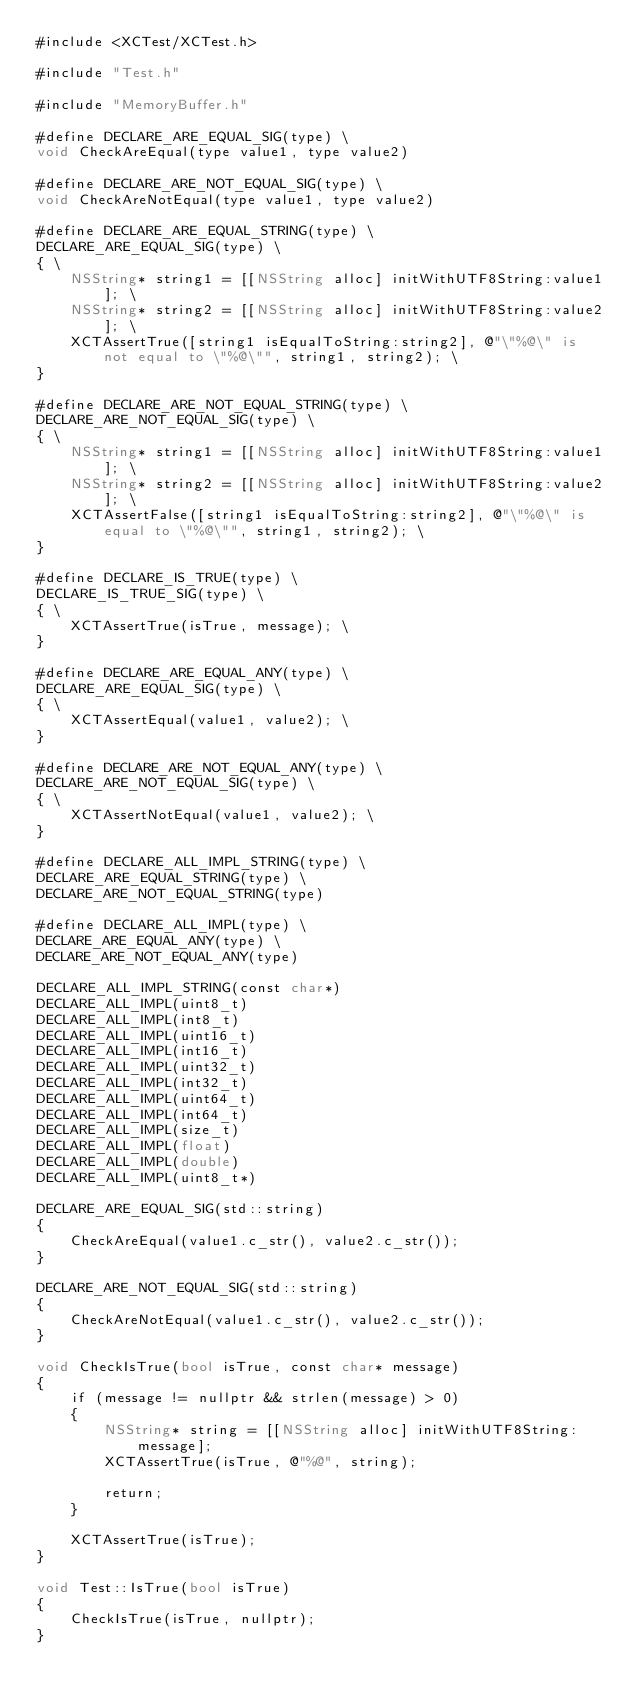Convert code to text. <code><loc_0><loc_0><loc_500><loc_500><_ObjectiveC_>#include <XCTest/XCTest.h>

#include "Test.h"

#include "MemoryBuffer.h"

#define DECLARE_ARE_EQUAL_SIG(type) \
void CheckAreEqual(type value1, type value2)

#define DECLARE_ARE_NOT_EQUAL_SIG(type) \
void CheckAreNotEqual(type value1, type value2)

#define DECLARE_ARE_EQUAL_STRING(type) \
DECLARE_ARE_EQUAL_SIG(type) \
{ \
    NSString* string1 = [[NSString alloc] initWithUTF8String:value1]; \
    NSString* string2 = [[NSString alloc] initWithUTF8String:value2]; \
    XCTAssertTrue([string1 isEqualToString:string2], @"\"%@\" is not equal to \"%@\"", string1, string2); \
}

#define DECLARE_ARE_NOT_EQUAL_STRING(type) \
DECLARE_ARE_NOT_EQUAL_SIG(type) \
{ \
    NSString* string1 = [[NSString alloc] initWithUTF8String:value1]; \
    NSString* string2 = [[NSString alloc] initWithUTF8String:value2]; \
    XCTAssertFalse([string1 isEqualToString:string2], @"\"%@\" is equal to \"%@\"", string1, string2); \
}

#define DECLARE_IS_TRUE(type) \
DECLARE_IS_TRUE_SIG(type) \
{ \
    XCTAssertTrue(isTrue, message); \
}

#define DECLARE_ARE_EQUAL_ANY(type) \
DECLARE_ARE_EQUAL_SIG(type) \
{ \
    XCTAssertEqual(value1, value2); \
}

#define DECLARE_ARE_NOT_EQUAL_ANY(type) \
DECLARE_ARE_NOT_EQUAL_SIG(type) \
{ \
    XCTAssertNotEqual(value1, value2); \
}

#define DECLARE_ALL_IMPL_STRING(type) \
DECLARE_ARE_EQUAL_STRING(type) \
DECLARE_ARE_NOT_EQUAL_STRING(type)

#define DECLARE_ALL_IMPL(type) \
DECLARE_ARE_EQUAL_ANY(type) \
DECLARE_ARE_NOT_EQUAL_ANY(type)

DECLARE_ALL_IMPL_STRING(const char*)
DECLARE_ALL_IMPL(uint8_t)
DECLARE_ALL_IMPL(int8_t)
DECLARE_ALL_IMPL(uint16_t)
DECLARE_ALL_IMPL(int16_t)
DECLARE_ALL_IMPL(uint32_t)
DECLARE_ALL_IMPL(int32_t)
DECLARE_ALL_IMPL(uint64_t)
DECLARE_ALL_IMPL(int64_t)
DECLARE_ALL_IMPL(size_t)
DECLARE_ALL_IMPL(float)
DECLARE_ALL_IMPL(double)
DECLARE_ALL_IMPL(uint8_t*)

DECLARE_ARE_EQUAL_SIG(std::string)
{
    CheckAreEqual(value1.c_str(), value2.c_str());
}

DECLARE_ARE_NOT_EQUAL_SIG(std::string)
{
    CheckAreNotEqual(value1.c_str(), value2.c_str());
}

void CheckIsTrue(bool isTrue, const char* message)
{
    if (message != nullptr && strlen(message) > 0)
    {
        NSString* string = [[NSString alloc] initWithUTF8String:message];
        XCTAssertTrue(isTrue, @"%@", string);
        
        return;
    }
    
    XCTAssertTrue(isTrue);
}

void Test::IsTrue(bool isTrue)
{
    CheckIsTrue(isTrue, nullptr);
}
</code> 